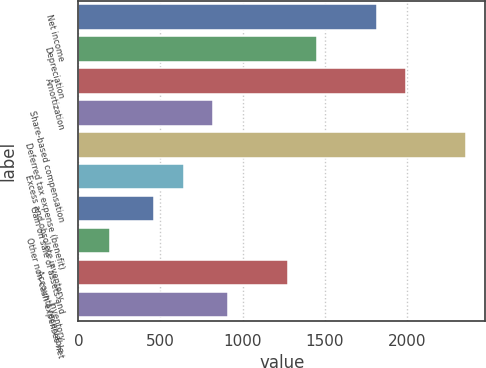Convert chart to OTSL. <chart><loc_0><loc_0><loc_500><loc_500><bar_chart><fcel>Net income<fcel>Depreciation<fcel>Amortization<fcel>Share-based compensation<fcel>Deferred tax expense (benefit)<fcel>Excess and obsolete inventory<fcel>Gain on sale of assets and<fcel>Other non-cash expenses net<fcel>Accounts receivable<fcel>Inventory<nl><fcel>1817<fcel>1455.4<fcel>1997.8<fcel>822.6<fcel>2359.4<fcel>641.8<fcel>461<fcel>189.8<fcel>1274.6<fcel>913<nl></chart> 